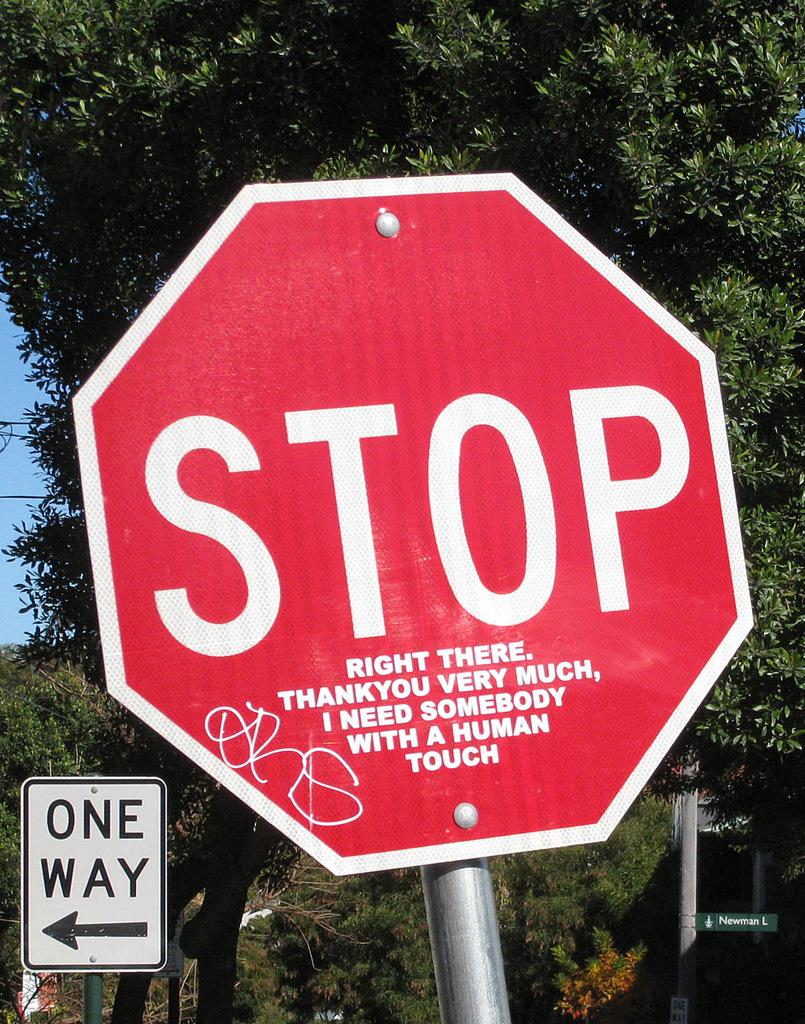<image>
Share a concise interpretation of the image provided. Someone added "right there..." to the stop sign to make it humorous. 